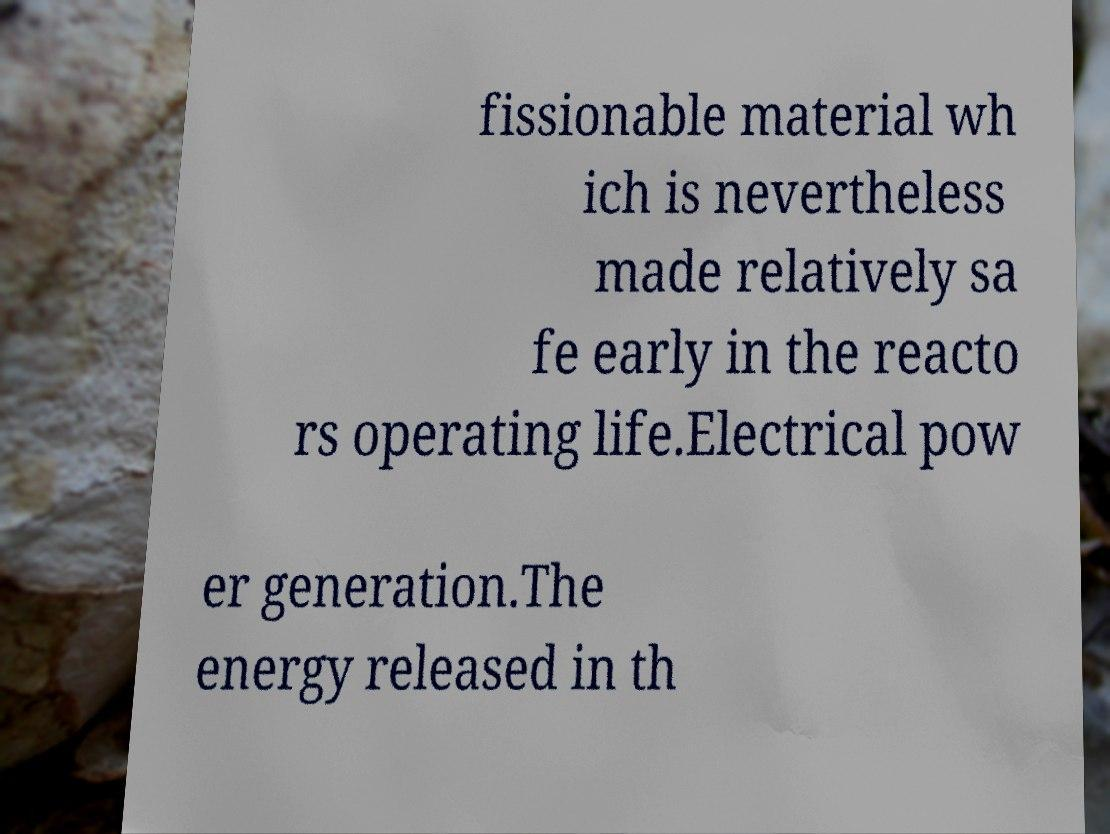What messages or text are displayed in this image? I need them in a readable, typed format. fissionable material wh ich is nevertheless made relatively sa fe early in the reacto rs operating life.Electrical pow er generation.The energy released in th 